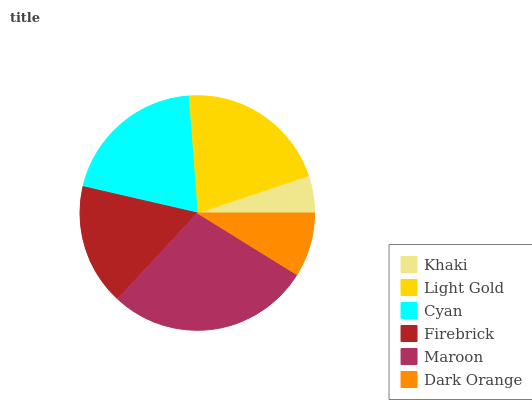Is Khaki the minimum?
Answer yes or no. Yes. Is Maroon the maximum?
Answer yes or no. Yes. Is Light Gold the minimum?
Answer yes or no. No. Is Light Gold the maximum?
Answer yes or no. No. Is Light Gold greater than Khaki?
Answer yes or no. Yes. Is Khaki less than Light Gold?
Answer yes or no. Yes. Is Khaki greater than Light Gold?
Answer yes or no. No. Is Light Gold less than Khaki?
Answer yes or no. No. Is Cyan the high median?
Answer yes or no. Yes. Is Firebrick the low median?
Answer yes or no. Yes. Is Dark Orange the high median?
Answer yes or no. No. Is Khaki the low median?
Answer yes or no. No. 